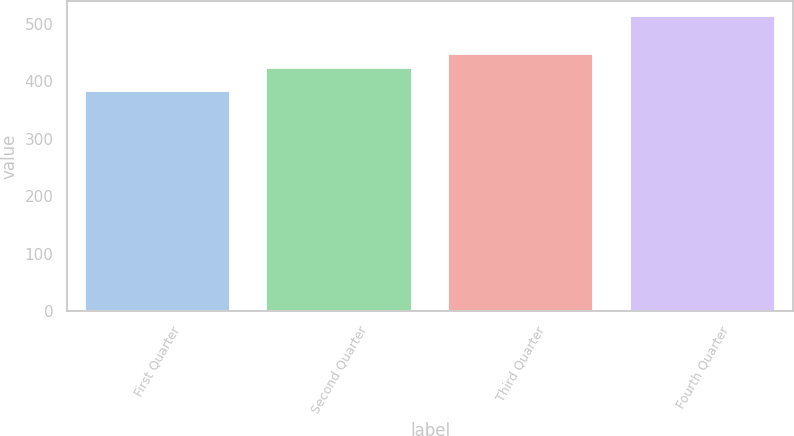Convert chart to OTSL. <chart><loc_0><loc_0><loc_500><loc_500><bar_chart><fcel>First Quarter<fcel>Second Quarter<fcel>Third Quarter<fcel>Fourth Quarter<nl><fcel>383.51<fcel>422.41<fcel>447.09<fcel>513.71<nl></chart> 